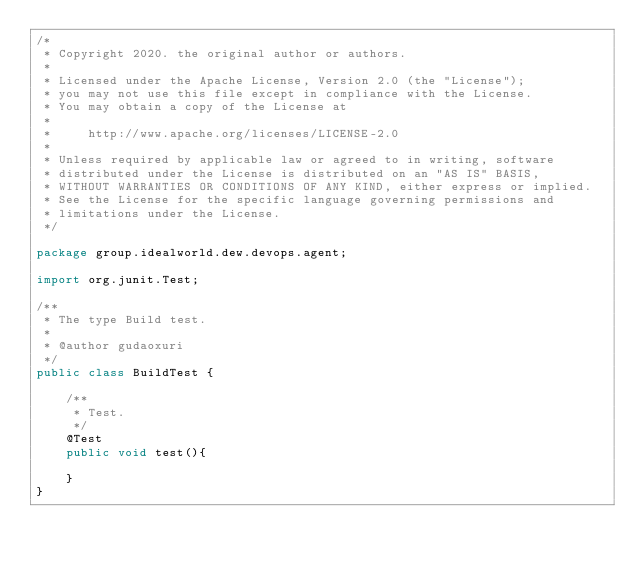<code> <loc_0><loc_0><loc_500><loc_500><_Java_>/*
 * Copyright 2020. the original author or authors.
 *
 * Licensed under the Apache License, Version 2.0 (the "License");
 * you may not use this file except in compliance with the License.
 * You may obtain a copy of the License at
 *
 *     http://www.apache.org/licenses/LICENSE-2.0
 *
 * Unless required by applicable law or agreed to in writing, software
 * distributed under the License is distributed on an "AS IS" BASIS,
 * WITHOUT WARRANTIES OR CONDITIONS OF ANY KIND, either express or implied.
 * See the License for the specific language governing permissions and
 * limitations under the License.
 */

package group.idealworld.dew.devops.agent;

import org.junit.Test;

/**
 * The type Build test.
 *
 * @author gudaoxuri
 */
public class BuildTest {

    /**
     * Test.
     */
    @Test
    public void test(){

    }
}
</code> 